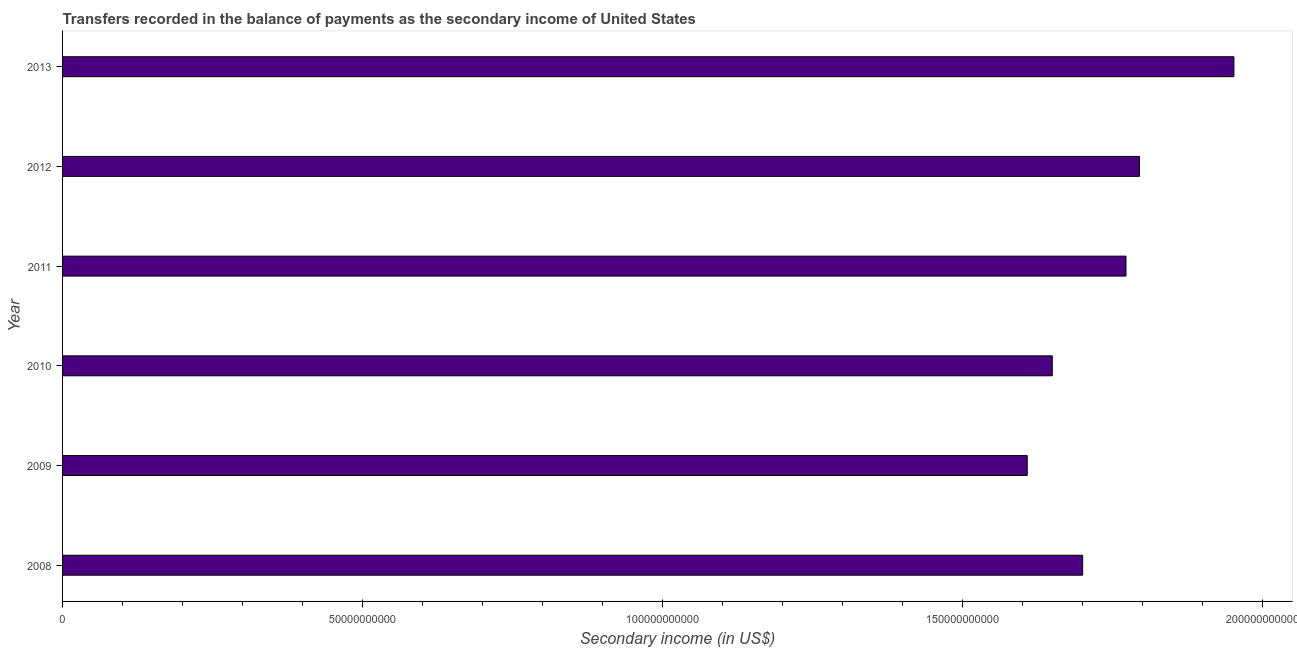Does the graph contain any zero values?
Ensure brevity in your answer.  No. Does the graph contain grids?
Provide a short and direct response. No. What is the title of the graph?
Give a very brief answer. Transfers recorded in the balance of payments as the secondary income of United States. What is the label or title of the X-axis?
Give a very brief answer. Secondary income (in US$). What is the label or title of the Y-axis?
Your answer should be compact. Year. What is the amount of secondary income in 2012?
Offer a very short reply. 1.79e+11. Across all years, what is the maximum amount of secondary income?
Offer a very short reply. 1.95e+11. Across all years, what is the minimum amount of secondary income?
Ensure brevity in your answer.  1.61e+11. What is the sum of the amount of secondary income?
Ensure brevity in your answer.  1.05e+12. What is the difference between the amount of secondary income in 2010 and 2012?
Offer a very short reply. -1.45e+1. What is the average amount of secondary income per year?
Provide a short and direct response. 1.75e+11. What is the median amount of secondary income?
Make the answer very short. 1.74e+11. In how many years, is the amount of secondary income greater than 190000000000 US$?
Your response must be concise. 1. What is the ratio of the amount of secondary income in 2008 to that in 2013?
Provide a succinct answer. 0.87. Is the amount of secondary income in 2011 less than that in 2013?
Provide a short and direct response. Yes. What is the difference between the highest and the second highest amount of secondary income?
Your answer should be very brief. 1.57e+1. Is the sum of the amount of secondary income in 2009 and 2010 greater than the maximum amount of secondary income across all years?
Give a very brief answer. Yes. What is the difference between the highest and the lowest amount of secondary income?
Your answer should be compact. 3.44e+1. Are all the bars in the graph horizontal?
Give a very brief answer. Yes. What is the difference between two consecutive major ticks on the X-axis?
Offer a terse response. 5.00e+1. Are the values on the major ticks of X-axis written in scientific E-notation?
Make the answer very short. No. What is the Secondary income (in US$) of 2008?
Your answer should be compact. 1.70e+11. What is the Secondary income (in US$) in 2009?
Provide a succinct answer. 1.61e+11. What is the Secondary income (in US$) of 2010?
Ensure brevity in your answer.  1.65e+11. What is the Secondary income (in US$) in 2011?
Offer a terse response. 1.77e+11. What is the Secondary income (in US$) of 2012?
Make the answer very short. 1.79e+11. What is the Secondary income (in US$) in 2013?
Offer a terse response. 1.95e+11. What is the difference between the Secondary income (in US$) in 2008 and 2009?
Make the answer very short. 9.24e+09. What is the difference between the Secondary income (in US$) in 2008 and 2010?
Your response must be concise. 5.06e+09. What is the difference between the Secondary income (in US$) in 2008 and 2011?
Offer a terse response. -7.22e+09. What is the difference between the Secondary income (in US$) in 2008 and 2012?
Make the answer very short. -9.47e+09. What is the difference between the Secondary income (in US$) in 2008 and 2013?
Give a very brief answer. -2.52e+1. What is the difference between the Secondary income (in US$) in 2009 and 2010?
Your answer should be very brief. -4.17e+09. What is the difference between the Secondary income (in US$) in 2009 and 2011?
Ensure brevity in your answer.  -1.65e+1. What is the difference between the Secondary income (in US$) in 2009 and 2012?
Your answer should be compact. -1.87e+1. What is the difference between the Secondary income (in US$) in 2009 and 2013?
Your response must be concise. -3.44e+1. What is the difference between the Secondary income (in US$) in 2010 and 2011?
Keep it short and to the point. -1.23e+1. What is the difference between the Secondary income (in US$) in 2010 and 2012?
Your answer should be very brief. -1.45e+1. What is the difference between the Secondary income (in US$) in 2010 and 2013?
Keep it short and to the point. -3.03e+1. What is the difference between the Secondary income (in US$) in 2011 and 2012?
Provide a short and direct response. -2.25e+09. What is the difference between the Secondary income (in US$) in 2011 and 2013?
Offer a terse response. -1.80e+1. What is the difference between the Secondary income (in US$) in 2012 and 2013?
Your response must be concise. -1.57e+1. What is the ratio of the Secondary income (in US$) in 2008 to that in 2009?
Your answer should be compact. 1.06. What is the ratio of the Secondary income (in US$) in 2008 to that in 2010?
Your answer should be compact. 1.03. What is the ratio of the Secondary income (in US$) in 2008 to that in 2011?
Offer a very short reply. 0.96. What is the ratio of the Secondary income (in US$) in 2008 to that in 2012?
Make the answer very short. 0.95. What is the ratio of the Secondary income (in US$) in 2008 to that in 2013?
Offer a very short reply. 0.87. What is the ratio of the Secondary income (in US$) in 2009 to that in 2010?
Offer a terse response. 0.97. What is the ratio of the Secondary income (in US$) in 2009 to that in 2011?
Offer a very short reply. 0.91. What is the ratio of the Secondary income (in US$) in 2009 to that in 2012?
Your answer should be compact. 0.9. What is the ratio of the Secondary income (in US$) in 2009 to that in 2013?
Offer a terse response. 0.82. What is the ratio of the Secondary income (in US$) in 2010 to that in 2011?
Provide a succinct answer. 0.93. What is the ratio of the Secondary income (in US$) in 2010 to that in 2012?
Offer a terse response. 0.92. What is the ratio of the Secondary income (in US$) in 2010 to that in 2013?
Your response must be concise. 0.84. What is the ratio of the Secondary income (in US$) in 2011 to that in 2012?
Keep it short and to the point. 0.99. What is the ratio of the Secondary income (in US$) in 2011 to that in 2013?
Keep it short and to the point. 0.91. What is the ratio of the Secondary income (in US$) in 2012 to that in 2013?
Your answer should be very brief. 0.92. 